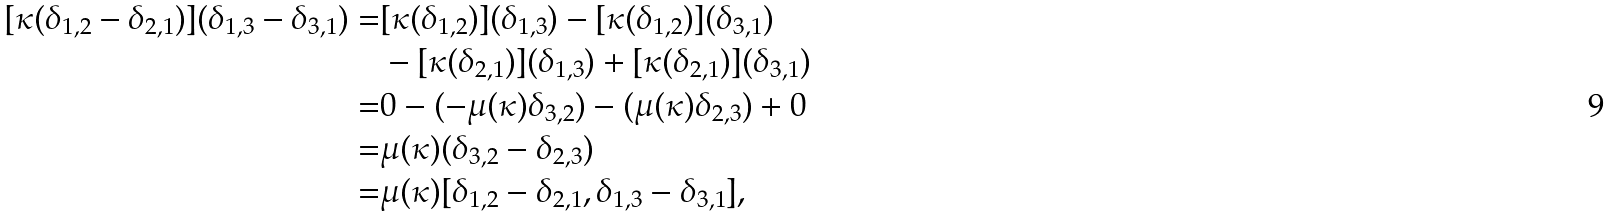<formula> <loc_0><loc_0><loc_500><loc_500>[ \kappa ( \delta _ { 1 , 2 } - \delta _ { 2 , 1 } ) ] ( \delta _ { 1 , 3 } - \delta _ { 3 , 1 } ) = & [ \kappa ( \delta _ { 1 , 2 } ) ] ( \delta _ { 1 , 3 } ) - [ \kappa ( \delta _ { 1 , 2 } ) ] ( \delta _ { 3 , 1 } ) \\ & - [ \kappa ( \delta _ { 2 , 1 } ) ] ( \delta _ { 1 , 3 } ) + [ \kappa ( \delta _ { 2 , 1 } ) ] ( \delta _ { 3 , 1 } ) \\ = & 0 - ( - \mu ( \kappa ) \delta _ { 3 , 2 } ) - ( \mu ( \kappa ) \delta _ { 2 , 3 } ) + 0 \\ = & \mu ( \kappa ) ( \delta _ { 3 , 2 } - \delta _ { 2 , 3 } ) \\ = & \mu ( \kappa ) [ \delta _ { 1 , 2 } - \delta _ { 2 , 1 } , \delta _ { 1 , 3 } - \delta _ { 3 , 1 } ] ,</formula> 